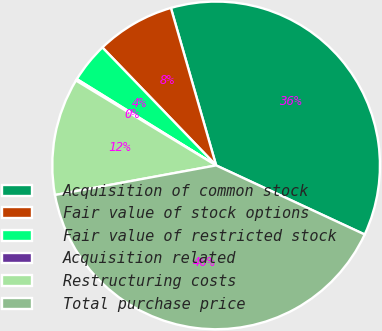Convert chart to OTSL. <chart><loc_0><loc_0><loc_500><loc_500><pie_chart><fcel>Acquisition of common stock<fcel>Fair value of stock options<fcel>Fair value of restricted stock<fcel>Acquisition related<fcel>Restructuring costs<fcel>Total purchase price<nl><fcel>36.38%<fcel>7.76%<fcel>3.96%<fcel>0.16%<fcel>11.56%<fcel>40.18%<nl></chart> 